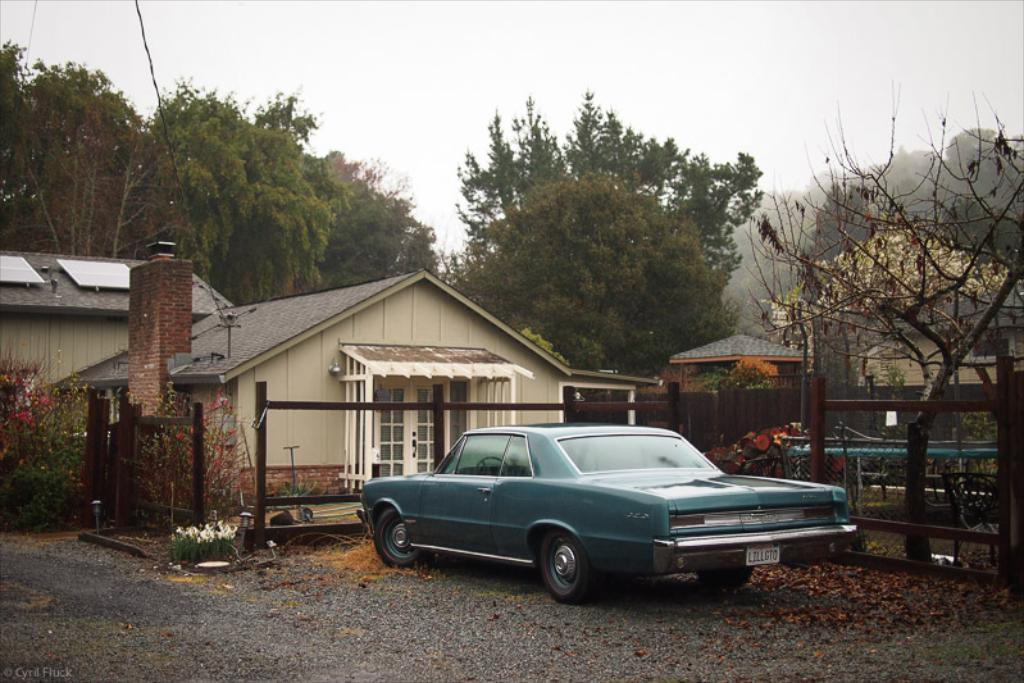What color is the car in the image? The car in the image is blue. Where is the car located in relation to the building? The car is parked in front of a building. What type of fence surrounds the building? There is a wooden fence around the building. What can be seen in the background of the image? There are trees, plants, and buildings in the background of the image. What is the condition of the sky in the image? The sky is clear in the image. What type of account is being discussed in the image? There is no account being discussed in the image; it features a blue car parked in front of a building. How much growth can be observed in the plants in the image? The provided facts do not mention the growth of the plants, only their presence in the background. 